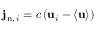<formula> <loc_0><loc_0><loc_500><loc_500>j _ { { n } , \, i } = c \left ( u _ { i } - \langle u \rangle \right )</formula> 